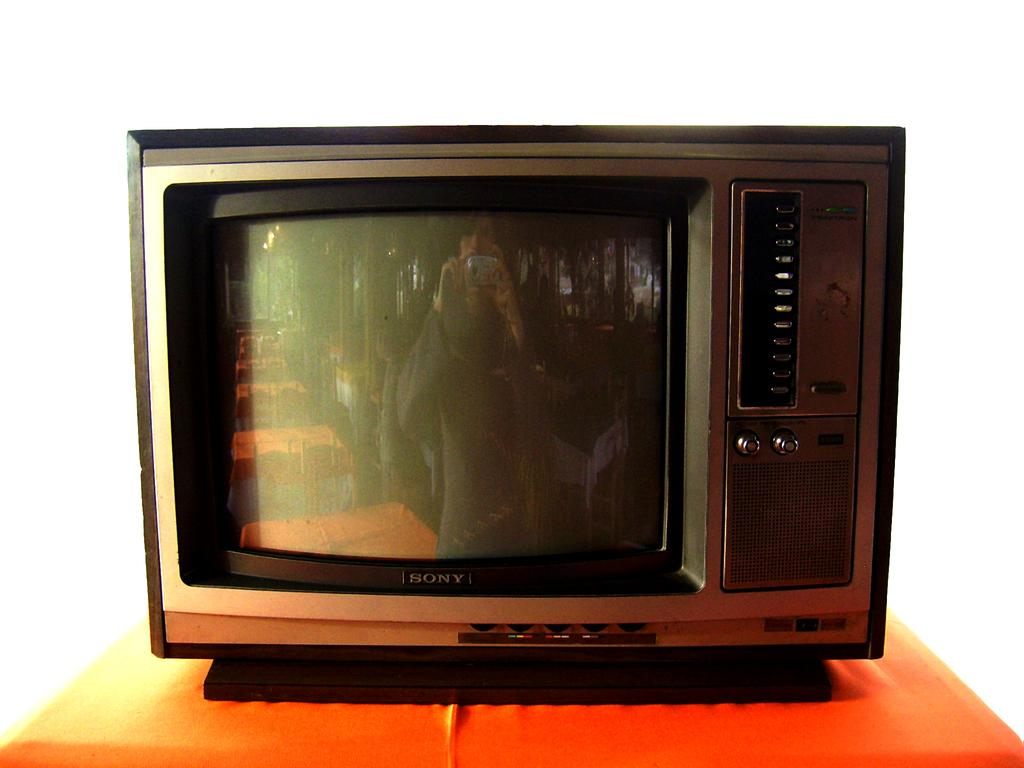<image>
Provide a brief description of the given image. An old Sony telelvision sitting out on a table. 